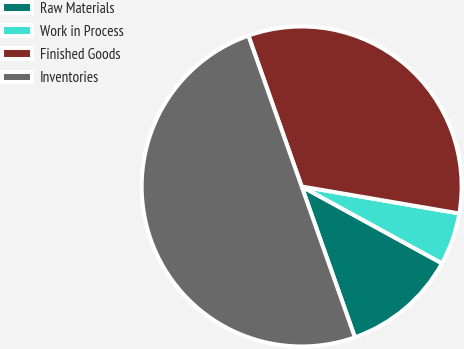Convert chart. <chart><loc_0><loc_0><loc_500><loc_500><pie_chart><fcel>Raw Materials<fcel>Work in Process<fcel>Finished Goods<fcel>Inventories<nl><fcel>11.62%<fcel>5.28%<fcel>33.1%<fcel>50.0%<nl></chart> 